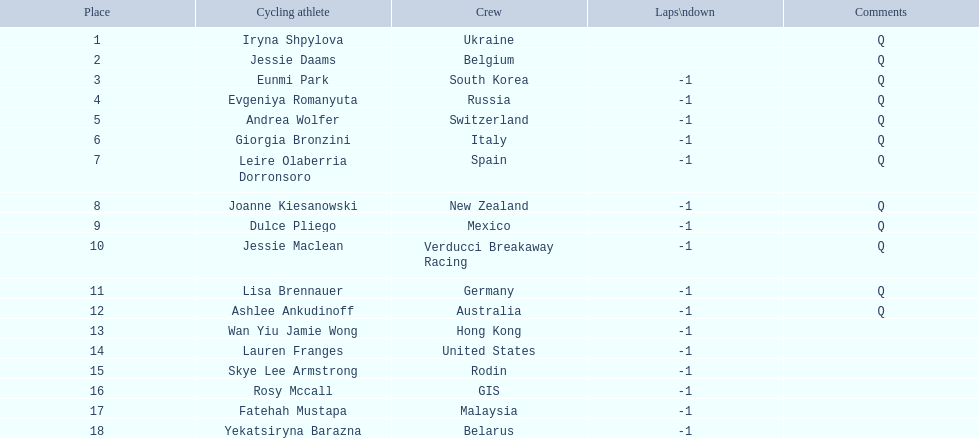Who are all the cyclists? Iryna Shpylova, Jessie Daams, Eunmi Park, Evgeniya Romanyuta, Andrea Wolfer, Giorgia Bronzini, Leire Olaberria Dorronsoro, Joanne Kiesanowski, Dulce Pliego, Jessie Maclean, Lisa Brennauer, Ashlee Ankudinoff, Wan Yiu Jamie Wong, Lauren Franges, Skye Lee Armstrong, Rosy Mccall, Fatehah Mustapa, Yekatsiryna Barazna. What were their ranks? 1, 2, 3, 4, 5, 6, 7, 8, 9, 10, 11, 12, 13, 14, 15, 16, 17, 18. Who was ranked highest? Iryna Shpylova. 